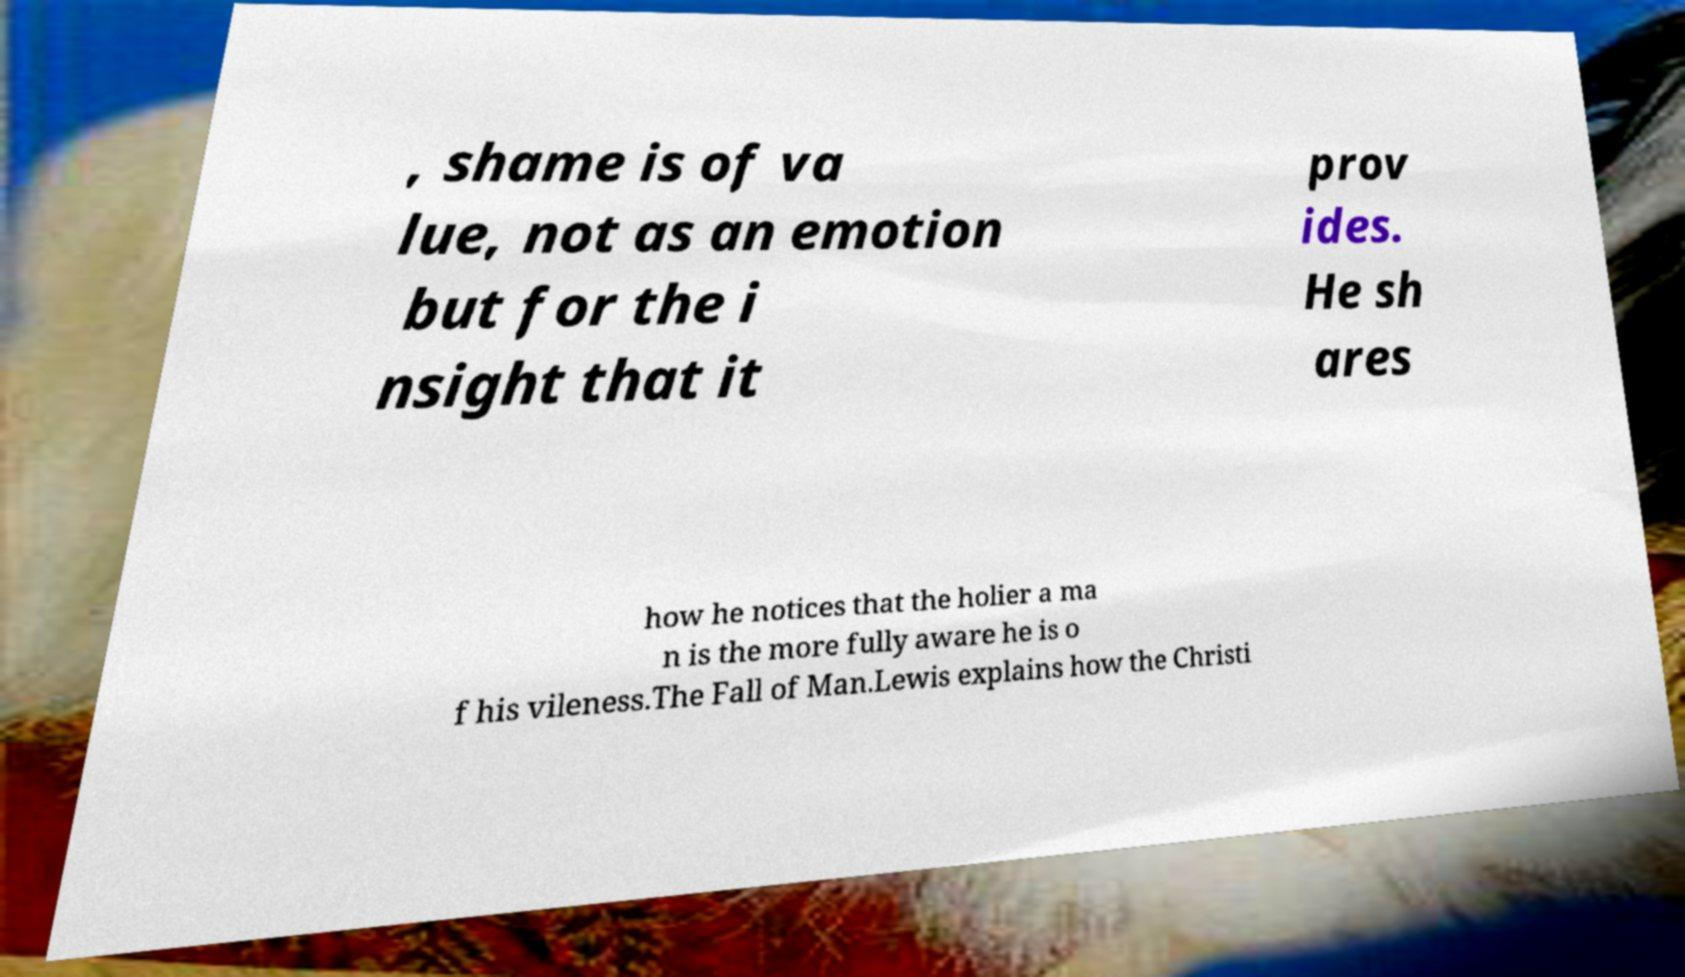Please read and relay the text visible in this image. What does it say? , shame is of va lue, not as an emotion but for the i nsight that it prov ides. He sh ares how he notices that the holier a ma n is the more fully aware he is o f his vileness.The Fall of Man.Lewis explains how the Christi 